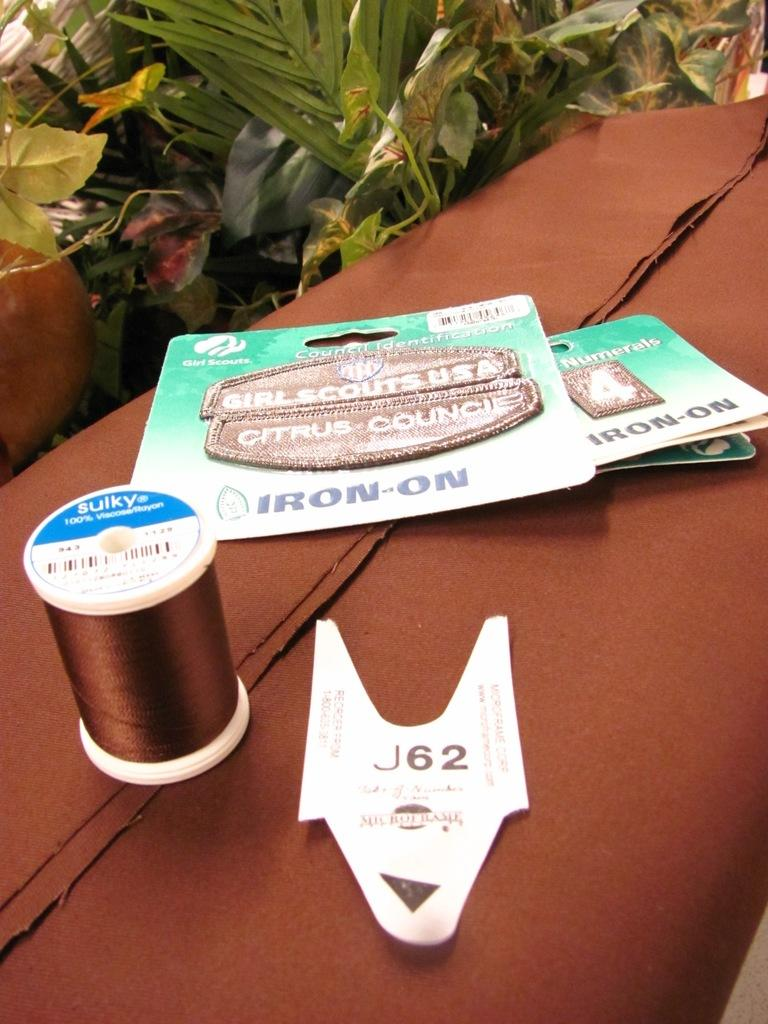What color is the cloth that is visible in the image? The cloth in the image is brown. What is on top of the brown cloth? There are items on the brown cloth. Are there any specific details about the brown cloth? Yes, there are brown threads on the cloth. What can be seen in the background behind the cloth? There are plants visible behind the cloth. What type of attack is being carried out by the ducks in the image? There are no ducks present in the image, so no attack can be observed. 